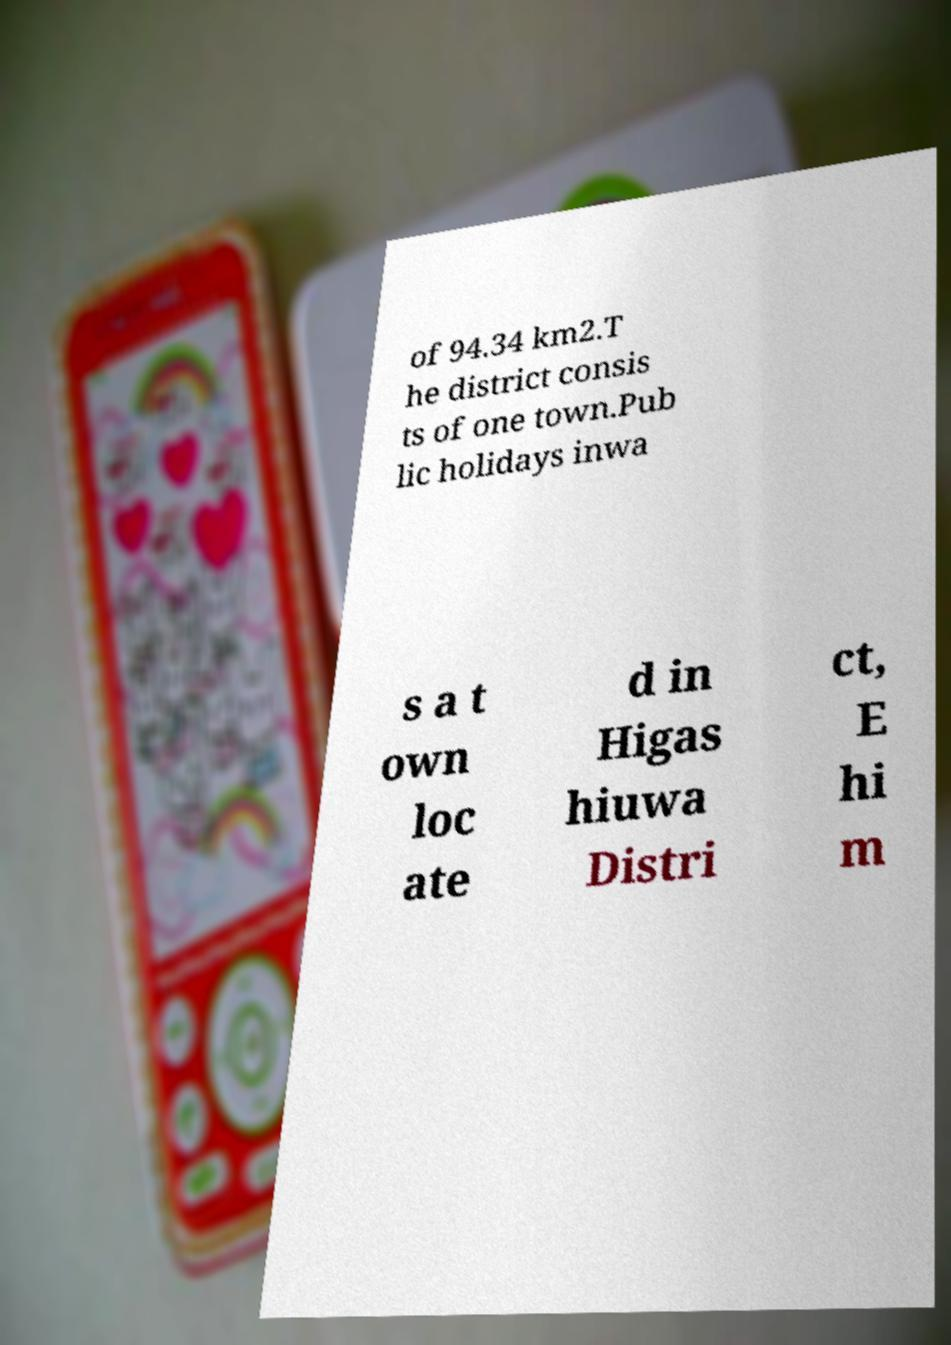I need the written content from this picture converted into text. Can you do that? of 94.34 km2.T he district consis ts of one town.Pub lic holidays inwa s a t own loc ate d in Higas hiuwa Distri ct, E hi m 